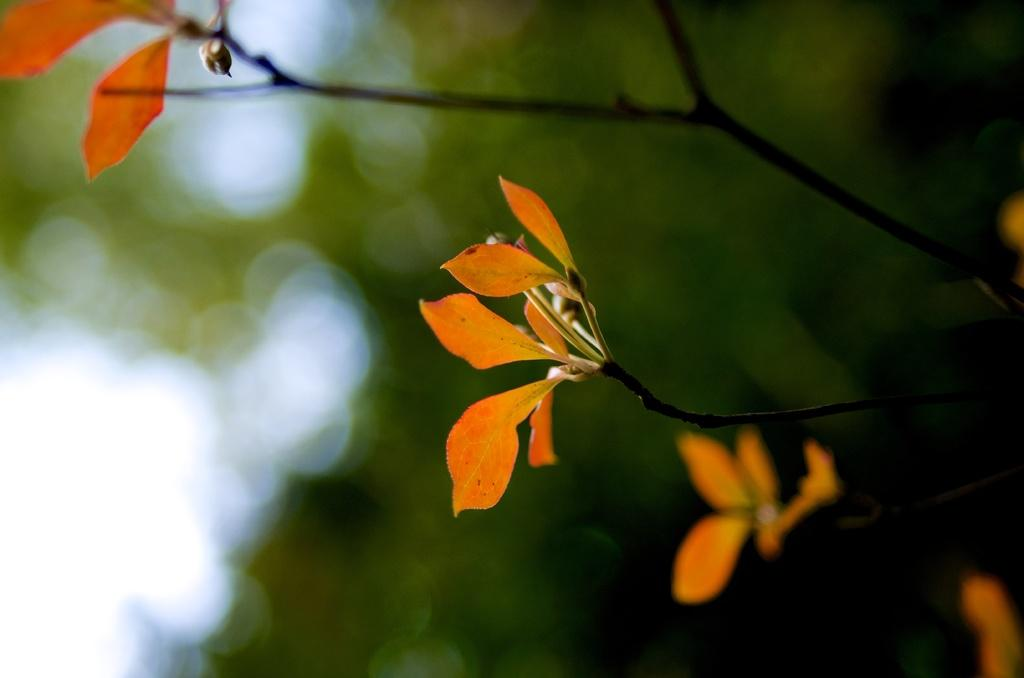What is the primary subject of the image? The primary subject of the image is many leaves. Can you describe the background of the image? The background of the image is blurred. What type of business is being conducted in the image? There is no indication of a business in the image; it primarily features leaves with a blurred background. What kind of rice can be seen in the image? There is no rice present in the image; it only contains leaves and a blurred background. 